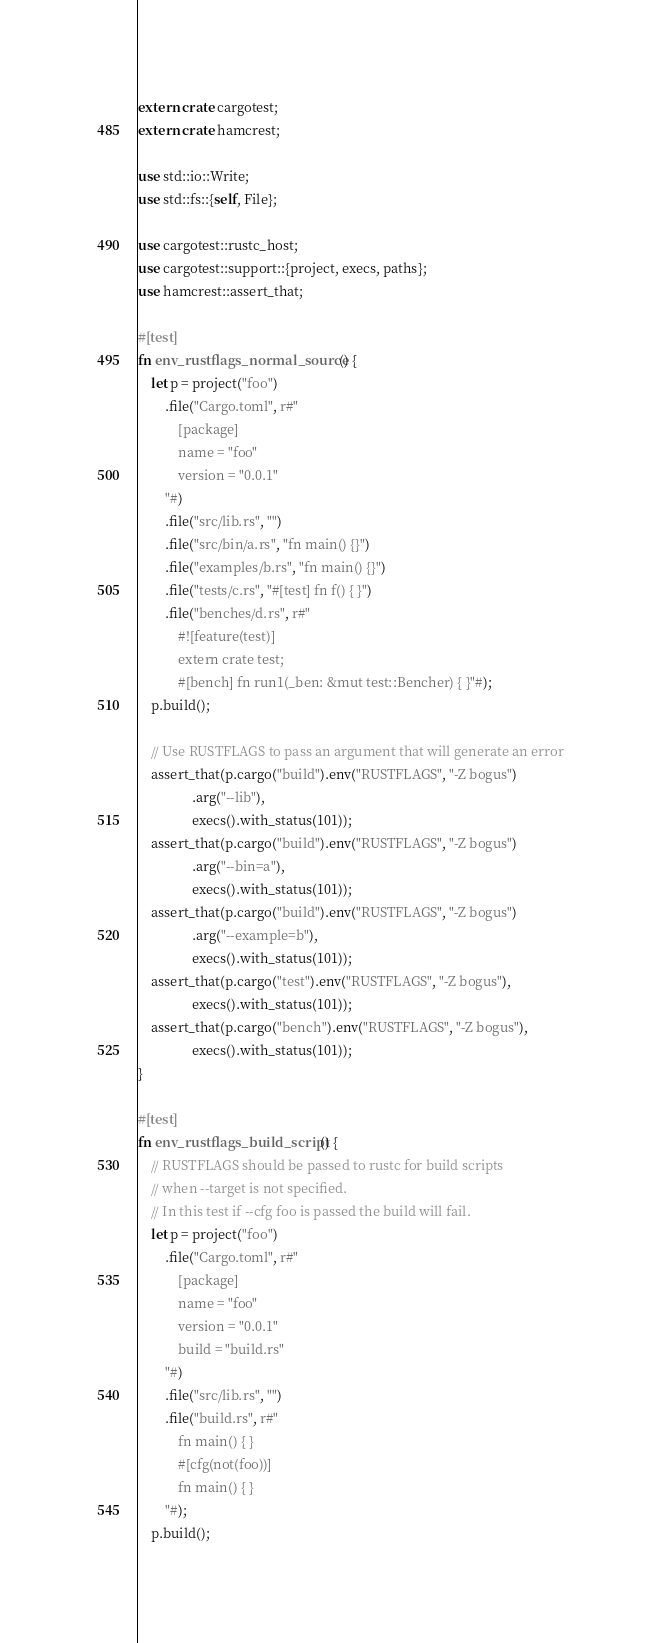<code> <loc_0><loc_0><loc_500><loc_500><_Rust_>extern crate cargotest;
extern crate hamcrest;

use std::io::Write;
use std::fs::{self, File};

use cargotest::rustc_host;
use cargotest::support::{project, execs, paths};
use hamcrest::assert_that;

#[test]
fn env_rustflags_normal_source() {
    let p = project("foo")
        .file("Cargo.toml", r#"
            [package]
            name = "foo"
            version = "0.0.1"
        "#)
        .file("src/lib.rs", "")
        .file("src/bin/a.rs", "fn main() {}")
        .file("examples/b.rs", "fn main() {}")
        .file("tests/c.rs", "#[test] fn f() { }")
        .file("benches/d.rs", r#"
            #![feature(test)]
            extern crate test;
            #[bench] fn run1(_ben: &mut test::Bencher) { }"#);
    p.build();

    // Use RUSTFLAGS to pass an argument that will generate an error
    assert_that(p.cargo("build").env("RUSTFLAGS", "-Z bogus")
                .arg("--lib"),
                execs().with_status(101));
    assert_that(p.cargo("build").env("RUSTFLAGS", "-Z bogus")
                .arg("--bin=a"),
                execs().with_status(101));
    assert_that(p.cargo("build").env("RUSTFLAGS", "-Z bogus")
                .arg("--example=b"),
                execs().with_status(101));
    assert_that(p.cargo("test").env("RUSTFLAGS", "-Z bogus"),
                execs().with_status(101));
    assert_that(p.cargo("bench").env("RUSTFLAGS", "-Z bogus"),
                execs().with_status(101));
}

#[test]
fn env_rustflags_build_script() {
    // RUSTFLAGS should be passed to rustc for build scripts
    // when --target is not specified.
    // In this test if --cfg foo is passed the build will fail.
    let p = project("foo")
        .file("Cargo.toml", r#"
            [package]
            name = "foo"
            version = "0.0.1"
            build = "build.rs"
        "#)
        .file("src/lib.rs", "")
        .file("build.rs", r#"
            fn main() { }
            #[cfg(not(foo))]
            fn main() { }
        "#);
    p.build();
</code> 